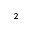<formula> <loc_0><loc_0><loc_500><loc_500>^ { 2 }</formula> 